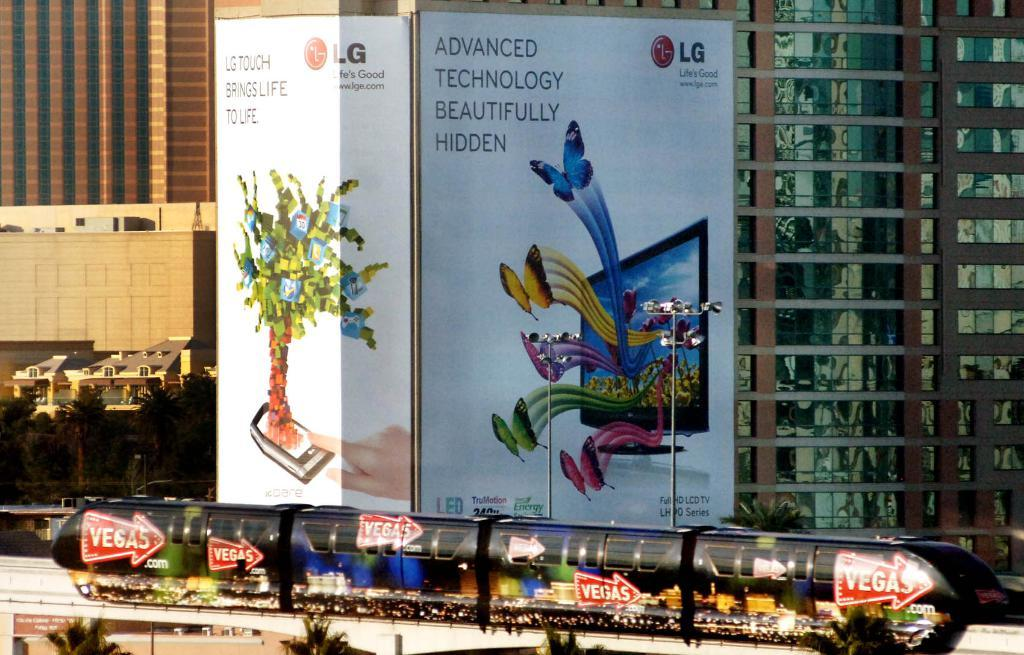<image>
Relay a brief, clear account of the picture shown. A advertisement for for LG displays hangs on an office building. 